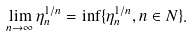Convert formula to latex. <formula><loc_0><loc_0><loc_500><loc_500>\lim _ { n \to \infty } \eta ^ { 1 / n } _ { n } = \inf \{ \eta ^ { 1 / n } _ { n } , n \in N \} .</formula> 